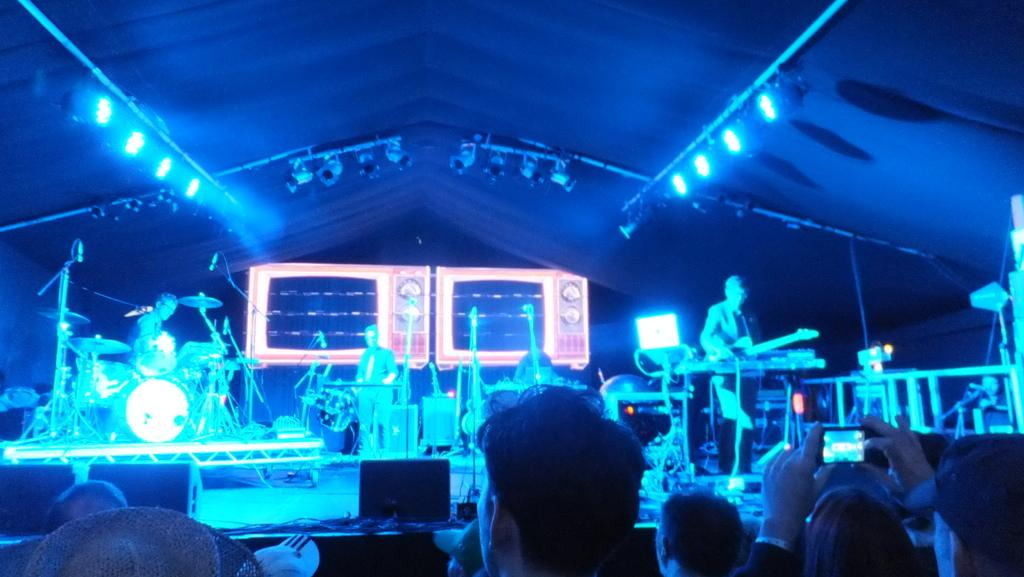What is happening in the image? There is a group of people in the image, and some of them are playing musical instruments on a stage. Can you describe the setting of the image? There are lights visible in the image, which suggests that the event is taking place in a well-lit area, possibly a performance venue or concert hall. What type of ring can be seen on the finger of the person playing the guitar in the image? There is no ring visible on the finger of the person playing the guitar in the image. Where is the cemetery located in the image? There is no cemetery present in the image; it features a group of people playing musical instruments on a stage. 